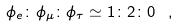Convert formula to latex. <formula><loc_0><loc_0><loc_500><loc_500>\phi _ { e } \colon \phi _ { \mu } \colon \phi _ { \tau } \simeq 1 \colon 2 \colon 0 \, \ ,</formula> 